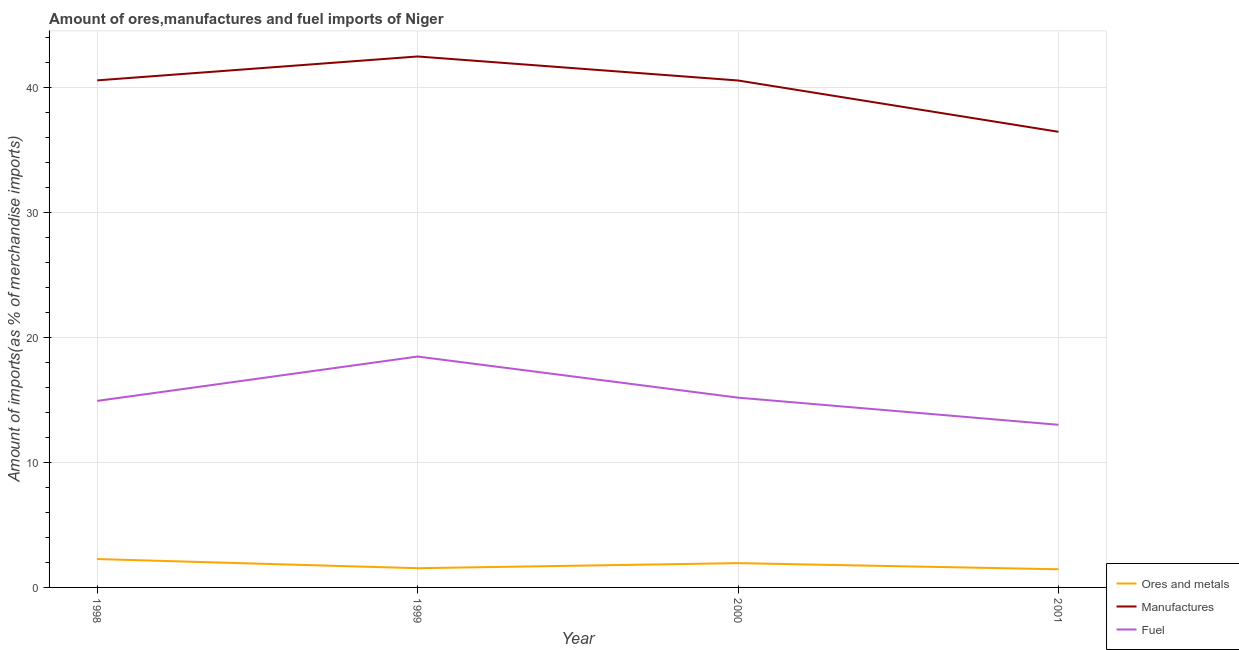Does the line corresponding to percentage of fuel imports intersect with the line corresponding to percentage of ores and metals imports?
Make the answer very short. No. What is the percentage of manufactures imports in 1999?
Offer a very short reply. 42.45. Across all years, what is the maximum percentage of ores and metals imports?
Ensure brevity in your answer.  2.27. Across all years, what is the minimum percentage of fuel imports?
Give a very brief answer. 13. What is the total percentage of fuel imports in the graph?
Keep it short and to the point. 61.55. What is the difference between the percentage of ores and metals imports in 1998 and that in 2000?
Ensure brevity in your answer.  0.33. What is the difference between the percentage of manufactures imports in 2001 and the percentage of fuel imports in 1998?
Give a very brief answer. 21.51. What is the average percentage of fuel imports per year?
Your answer should be very brief. 15.39. In the year 1998, what is the difference between the percentage of fuel imports and percentage of ores and metals imports?
Your answer should be compact. 12.64. What is the ratio of the percentage of ores and metals imports in 1999 to that in 2001?
Provide a short and direct response. 1.06. Is the difference between the percentage of ores and metals imports in 1998 and 1999 greater than the difference between the percentage of manufactures imports in 1998 and 1999?
Provide a short and direct response. Yes. What is the difference between the highest and the second highest percentage of fuel imports?
Provide a succinct answer. 3.29. What is the difference between the highest and the lowest percentage of fuel imports?
Offer a very short reply. 5.46. In how many years, is the percentage of manufactures imports greater than the average percentage of manufactures imports taken over all years?
Provide a short and direct response. 3. Is it the case that in every year, the sum of the percentage of ores and metals imports and percentage of manufactures imports is greater than the percentage of fuel imports?
Give a very brief answer. Yes. Is the percentage of manufactures imports strictly greater than the percentage of ores and metals imports over the years?
Your answer should be very brief. Yes. How many lines are there?
Provide a short and direct response. 3. How many years are there in the graph?
Provide a succinct answer. 4. What is the difference between two consecutive major ticks on the Y-axis?
Make the answer very short. 10. Are the values on the major ticks of Y-axis written in scientific E-notation?
Make the answer very short. No. Does the graph contain any zero values?
Provide a short and direct response. No. How are the legend labels stacked?
Give a very brief answer. Vertical. What is the title of the graph?
Give a very brief answer. Amount of ores,manufactures and fuel imports of Niger. Does "Neonatal" appear as one of the legend labels in the graph?
Provide a succinct answer. No. What is the label or title of the Y-axis?
Your answer should be very brief. Amount of imports(as % of merchandise imports). What is the Amount of imports(as % of merchandise imports) of Ores and metals in 1998?
Offer a terse response. 2.27. What is the Amount of imports(as % of merchandise imports) of Manufactures in 1998?
Your answer should be compact. 40.54. What is the Amount of imports(as % of merchandise imports) of Fuel in 1998?
Your answer should be compact. 14.91. What is the Amount of imports(as % of merchandise imports) in Ores and metals in 1999?
Provide a short and direct response. 1.54. What is the Amount of imports(as % of merchandise imports) in Manufactures in 1999?
Provide a succinct answer. 42.45. What is the Amount of imports(as % of merchandise imports) of Fuel in 1999?
Your answer should be compact. 18.46. What is the Amount of imports(as % of merchandise imports) of Ores and metals in 2000?
Offer a very short reply. 1.94. What is the Amount of imports(as % of merchandise imports) of Manufactures in 2000?
Give a very brief answer. 40.53. What is the Amount of imports(as % of merchandise imports) of Fuel in 2000?
Make the answer very short. 15.17. What is the Amount of imports(as % of merchandise imports) in Ores and metals in 2001?
Your answer should be very brief. 1.45. What is the Amount of imports(as % of merchandise imports) of Manufactures in 2001?
Your answer should be compact. 36.43. What is the Amount of imports(as % of merchandise imports) in Fuel in 2001?
Offer a terse response. 13. Across all years, what is the maximum Amount of imports(as % of merchandise imports) in Ores and metals?
Offer a very short reply. 2.27. Across all years, what is the maximum Amount of imports(as % of merchandise imports) of Manufactures?
Offer a terse response. 42.45. Across all years, what is the maximum Amount of imports(as % of merchandise imports) of Fuel?
Ensure brevity in your answer.  18.46. Across all years, what is the minimum Amount of imports(as % of merchandise imports) of Ores and metals?
Offer a terse response. 1.45. Across all years, what is the minimum Amount of imports(as % of merchandise imports) of Manufactures?
Offer a terse response. 36.43. Across all years, what is the minimum Amount of imports(as % of merchandise imports) of Fuel?
Give a very brief answer. 13. What is the total Amount of imports(as % of merchandise imports) in Ores and metals in the graph?
Your response must be concise. 7.2. What is the total Amount of imports(as % of merchandise imports) in Manufactures in the graph?
Give a very brief answer. 159.95. What is the total Amount of imports(as % of merchandise imports) in Fuel in the graph?
Provide a succinct answer. 61.55. What is the difference between the Amount of imports(as % of merchandise imports) in Ores and metals in 1998 and that in 1999?
Provide a succinct answer. 0.73. What is the difference between the Amount of imports(as % of merchandise imports) in Manufactures in 1998 and that in 1999?
Your answer should be compact. -1.91. What is the difference between the Amount of imports(as % of merchandise imports) in Fuel in 1998 and that in 1999?
Give a very brief answer. -3.55. What is the difference between the Amount of imports(as % of merchandise imports) in Ores and metals in 1998 and that in 2000?
Keep it short and to the point. 0.33. What is the difference between the Amount of imports(as % of merchandise imports) in Manufactures in 1998 and that in 2000?
Make the answer very short. 0.01. What is the difference between the Amount of imports(as % of merchandise imports) in Fuel in 1998 and that in 2000?
Ensure brevity in your answer.  -0.26. What is the difference between the Amount of imports(as % of merchandise imports) of Ores and metals in 1998 and that in 2001?
Your response must be concise. 0.82. What is the difference between the Amount of imports(as % of merchandise imports) of Manufactures in 1998 and that in 2001?
Make the answer very short. 4.11. What is the difference between the Amount of imports(as % of merchandise imports) of Fuel in 1998 and that in 2001?
Offer a very short reply. 1.91. What is the difference between the Amount of imports(as % of merchandise imports) of Ores and metals in 1999 and that in 2000?
Offer a very short reply. -0.41. What is the difference between the Amount of imports(as % of merchandise imports) in Manufactures in 1999 and that in 2000?
Your response must be concise. 1.92. What is the difference between the Amount of imports(as % of merchandise imports) in Fuel in 1999 and that in 2000?
Keep it short and to the point. 3.29. What is the difference between the Amount of imports(as % of merchandise imports) of Ores and metals in 1999 and that in 2001?
Provide a short and direct response. 0.08. What is the difference between the Amount of imports(as % of merchandise imports) in Manufactures in 1999 and that in 2001?
Provide a succinct answer. 6.02. What is the difference between the Amount of imports(as % of merchandise imports) of Fuel in 1999 and that in 2001?
Keep it short and to the point. 5.46. What is the difference between the Amount of imports(as % of merchandise imports) in Ores and metals in 2000 and that in 2001?
Your answer should be very brief. 0.49. What is the difference between the Amount of imports(as % of merchandise imports) of Manufactures in 2000 and that in 2001?
Make the answer very short. 4.1. What is the difference between the Amount of imports(as % of merchandise imports) in Fuel in 2000 and that in 2001?
Ensure brevity in your answer.  2.17. What is the difference between the Amount of imports(as % of merchandise imports) in Ores and metals in 1998 and the Amount of imports(as % of merchandise imports) in Manufactures in 1999?
Your answer should be very brief. -40.18. What is the difference between the Amount of imports(as % of merchandise imports) in Ores and metals in 1998 and the Amount of imports(as % of merchandise imports) in Fuel in 1999?
Your response must be concise. -16.19. What is the difference between the Amount of imports(as % of merchandise imports) in Manufactures in 1998 and the Amount of imports(as % of merchandise imports) in Fuel in 1999?
Provide a succinct answer. 22.08. What is the difference between the Amount of imports(as % of merchandise imports) of Ores and metals in 1998 and the Amount of imports(as % of merchandise imports) of Manufactures in 2000?
Provide a succinct answer. -38.26. What is the difference between the Amount of imports(as % of merchandise imports) of Ores and metals in 1998 and the Amount of imports(as % of merchandise imports) of Fuel in 2000?
Your answer should be compact. -12.9. What is the difference between the Amount of imports(as % of merchandise imports) in Manufactures in 1998 and the Amount of imports(as % of merchandise imports) in Fuel in 2000?
Offer a very short reply. 25.37. What is the difference between the Amount of imports(as % of merchandise imports) of Ores and metals in 1998 and the Amount of imports(as % of merchandise imports) of Manufactures in 2001?
Keep it short and to the point. -34.16. What is the difference between the Amount of imports(as % of merchandise imports) in Ores and metals in 1998 and the Amount of imports(as % of merchandise imports) in Fuel in 2001?
Ensure brevity in your answer.  -10.73. What is the difference between the Amount of imports(as % of merchandise imports) in Manufactures in 1998 and the Amount of imports(as % of merchandise imports) in Fuel in 2001?
Your response must be concise. 27.54. What is the difference between the Amount of imports(as % of merchandise imports) of Ores and metals in 1999 and the Amount of imports(as % of merchandise imports) of Manufactures in 2000?
Provide a succinct answer. -38.99. What is the difference between the Amount of imports(as % of merchandise imports) of Ores and metals in 1999 and the Amount of imports(as % of merchandise imports) of Fuel in 2000?
Your response must be concise. -13.64. What is the difference between the Amount of imports(as % of merchandise imports) of Manufactures in 1999 and the Amount of imports(as % of merchandise imports) of Fuel in 2000?
Make the answer very short. 27.28. What is the difference between the Amount of imports(as % of merchandise imports) in Ores and metals in 1999 and the Amount of imports(as % of merchandise imports) in Manufactures in 2001?
Give a very brief answer. -34.89. What is the difference between the Amount of imports(as % of merchandise imports) of Ores and metals in 1999 and the Amount of imports(as % of merchandise imports) of Fuel in 2001?
Your answer should be compact. -11.47. What is the difference between the Amount of imports(as % of merchandise imports) in Manufactures in 1999 and the Amount of imports(as % of merchandise imports) in Fuel in 2001?
Keep it short and to the point. 29.45. What is the difference between the Amount of imports(as % of merchandise imports) of Ores and metals in 2000 and the Amount of imports(as % of merchandise imports) of Manufactures in 2001?
Make the answer very short. -34.49. What is the difference between the Amount of imports(as % of merchandise imports) in Ores and metals in 2000 and the Amount of imports(as % of merchandise imports) in Fuel in 2001?
Offer a terse response. -11.06. What is the difference between the Amount of imports(as % of merchandise imports) of Manufactures in 2000 and the Amount of imports(as % of merchandise imports) of Fuel in 2001?
Keep it short and to the point. 27.53. What is the average Amount of imports(as % of merchandise imports) in Ores and metals per year?
Offer a very short reply. 1.8. What is the average Amount of imports(as % of merchandise imports) in Manufactures per year?
Offer a terse response. 39.99. What is the average Amount of imports(as % of merchandise imports) in Fuel per year?
Make the answer very short. 15.39. In the year 1998, what is the difference between the Amount of imports(as % of merchandise imports) in Ores and metals and Amount of imports(as % of merchandise imports) in Manufactures?
Provide a succinct answer. -38.27. In the year 1998, what is the difference between the Amount of imports(as % of merchandise imports) of Ores and metals and Amount of imports(as % of merchandise imports) of Fuel?
Provide a succinct answer. -12.64. In the year 1998, what is the difference between the Amount of imports(as % of merchandise imports) in Manufactures and Amount of imports(as % of merchandise imports) in Fuel?
Your answer should be compact. 25.63. In the year 1999, what is the difference between the Amount of imports(as % of merchandise imports) in Ores and metals and Amount of imports(as % of merchandise imports) in Manufactures?
Provide a succinct answer. -40.91. In the year 1999, what is the difference between the Amount of imports(as % of merchandise imports) in Ores and metals and Amount of imports(as % of merchandise imports) in Fuel?
Ensure brevity in your answer.  -16.92. In the year 1999, what is the difference between the Amount of imports(as % of merchandise imports) in Manufactures and Amount of imports(as % of merchandise imports) in Fuel?
Your answer should be very brief. 23.99. In the year 2000, what is the difference between the Amount of imports(as % of merchandise imports) of Ores and metals and Amount of imports(as % of merchandise imports) of Manufactures?
Make the answer very short. -38.59. In the year 2000, what is the difference between the Amount of imports(as % of merchandise imports) in Ores and metals and Amount of imports(as % of merchandise imports) in Fuel?
Make the answer very short. -13.23. In the year 2000, what is the difference between the Amount of imports(as % of merchandise imports) in Manufactures and Amount of imports(as % of merchandise imports) in Fuel?
Provide a short and direct response. 25.36. In the year 2001, what is the difference between the Amount of imports(as % of merchandise imports) in Ores and metals and Amount of imports(as % of merchandise imports) in Manufactures?
Your response must be concise. -34.98. In the year 2001, what is the difference between the Amount of imports(as % of merchandise imports) in Ores and metals and Amount of imports(as % of merchandise imports) in Fuel?
Ensure brevity in your answer.  -11.55. In the year 2001, what is the difference between the Amount of imports(as % of merchandise imports) of Manufactures and Amount of imports(as % of merchandise imports) of Fuel?
Provide a short and direct response. 23.43. What is the ratio of the Amount of imports(as % of merchandise imports) in Ores and metals in 1998 to that in 1999?
Provide a short and direct response. 1.48. What is the ratio of the Amount of imports(as % of merchandise imports) of Manufactures in 1998 to that in 1999?
Your answer should be compact. 0.95. What is the ratio of the Amount of imports(as % of merchandise imports) in Fuel in 1998 to that in 1999?
Offer a terse response. 0.81. What is the ratio of the Amount of imports(as % of merchandise imports) of Ores and metals in 1998 to that in 2000?
Provide a short and direct response. 1.17. What is the ratio of the Amount of imports(as % of merchandise imports) of Fuel in 1998 to that in 2000?
Ensure brevity in your answer.  0.98. What is the ratio of the Amount of imports(as % of merchandise imports) of Ores and metals in 1998 to that in 2001?
Your answer should be compact. 1.56. What is the ratio of the Amount of imports(as % of merchandise imports) of Manufactures in 1998 to that in 2001?
Your response must be concise. 1.11. What is the ratio of the Amount of imports(as % of merchandise imports) of Fuel in 1998 to that in 2001?
Offer a very short reply. 1.15. What is the ratio of the Amount of imports(as % of merchandise imports) of Ores and metals in 1999 to that in 2000?
Make the answer very short. 0.79. What is the ratio of the Amount of imports(as % of merchandise imports) of Manufactures in 1999 to that in 2000?
Give a very brief answer. 1.05. What is the ratio of the Amount of imports(as % of merchandise imports) in Fuel in 1999 to that in 2000?
Offer a terse response. 1.22. What is the ratio of the Amount of imports(as % of merchandise imports) in Ores and metals in 1999 to that in 2001?
Offer a terse response. 1.06. What is the ratio of the Amount of imports(as % of merchandise imports) in Manufactures in 1999 to that in 2001?
Your answer should be compact. 1.17. What is the ratio of the Amount of imports(as % of merchandise imports) in Fuel in 1999 to that in 2001?
Offer a terse response. 1.42. What is the ratio of the Amount of imports(as % of merchandise imports) in Ores and metals in 2000 to that in 2001?
Ensure brevity in your answer.  1.34. What is the ratio of the Amount of imports(as % of merchandise imports) in Manufactures in 2000 to that in 2001?
Offer a terse response. 1.11. What is the ratio of the Amount of imports(as % of merchandise imports) of Fuel in 2000 to that in 2001?
Offer a very short reply. 1.17. What is the difference between the highest and the second highest Amount of imports(as % of merchandise imports) of Ores and metals?
Your answer should be very brief. 0.33. What is the difference between the highest and the second highest Amount of imports(as % of merchandise imports) of Manufactures?
Keep it short and to the point. 1.91. What is the difference between the highest and the second highest Amount of imports(as % of merchandise imports) in Fuel?
Provide a succinct answer. 3.29. What is the difference between the highest and the lowest Amount of imports(as % of merchandise imports) in Ores and metals?
Provide a short and direct response. 0.82. What is the difference between the highest and the lowest Amount of imports(as % of merchandise imports) in Manufactures?
Make the answer very short. 6.02. What is the difference between the highest and the lowest Amount of imports(as % of merchandise imports) of Fuel?
Give a very brief answer. 5.46. 